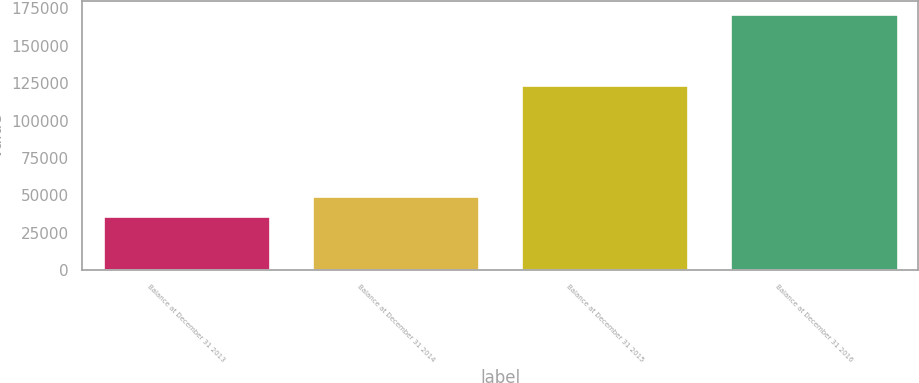Convert chart. <chart><loc_0><loc_0><loc_500><loc_500><bar_chart><fcel>Balance at December 31 2013<fcel>Balance at December 31 2014<fcel>Balance at December 31 2015<fcel>Balance at December 31 2016<nl><fcel>36294<fcel>49819<fcel>123794<fcel>171544<nl></chart> 